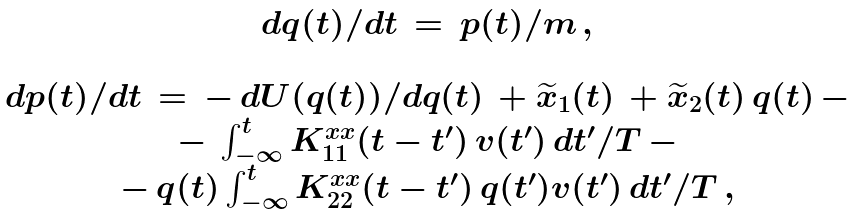Convert formula to latex. <formula><loc_0><loc_0><loc_500><loc_500>\begin{array} { c } d q ( t ) / d t \, = \, p ( t ) / m \, , \\ \, \\ d p ( t ) / d t \, = \, - \, d U ( q ( t ) ) / d q ( t ) \, + \widetilde { x } _ { 1 } ( t ) \, + \widetilde { x } _ { 2 } ( t ) \, q ( t ) \, - \\ - \, \int ^ { t } _ { - \infty } K _ { 1 1 } ^ { x x } ( t - t ^ { \prime } ) \, v ( t ^ { \prime } ) \, d t ^ { \prime } / T \, - \\ - \, q ( t ) \int ^ { t } _ { - \infty } K _ { 2 2 } ^ { x x } ( t - t ^ { \prime } ) \, q ( t ^ { \prime } ) v ( t ^ { \prime } ) \, d t ^ { \prime } / T \, , \end{array}</formula> 